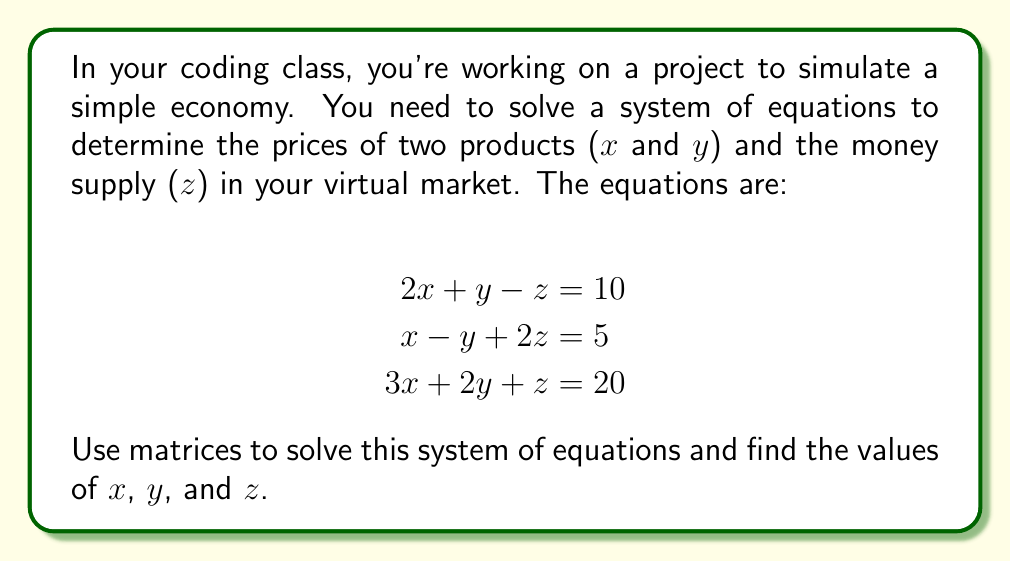Solve this math problem. Let's solve this step-by-step using matrices:

1) First, we'll set up the augmented matrix:

   $$\left[\begin{array}{ccc|c}
   2 & 1 & -1 & 10 \\
   1 & -1 & 2 & 5 \\
   3 & 2 & 1 & 20
   \end{array}\right]$$

2) Now, we'll use Gaussian elimination to convert this to row echelon form:

   R2 → R2 - $\frac{1}{2}$R1:
   $$\left[\begin{array}{ccc|c}
   2 & 1 & -1 & 10 \\
   0 & -\frac{3}{2} & \frac{5}{2} & 0 \\
   3 & 2 & 1 & 20
   \end{array}\right]$$

   R3 → R3 - $\frac{3}{2}$R1:
   $$\left[\begin{array}{ccc|c}
   2 & 1 & -1 & 10 \\
   0 & -\frac{3}{2} & \frac{5}{2} & 0 \\
   0 & \frac{1}{2} & \frac{5}{2} & 5
   \end{array}\right]$$

3) Now, R3 → R3 + $\frac{1}{3}$R2:
   $$\left[\begin{array}{ccc|c}
   2 & 1 & -1 & 10 \\
   0 & -\frac{3}{2} & \frac{5}{2} & 0 \\
   0 & 0 & 3 & 5
   \end{array}\right]$$

4) We now have the matrix in row echelon form. Let's solve from bottom to top:

   From the last row: $3z = 5$, so $z = \frac{5}{3}$

   From the second row: $-\frac{3}{2}y + \frac{5}{2}(\frac{5}{3}) = 0$
                        $-\frac{3}{2}y + \frac{25}{6} = 0$
                        $y = \frac{25}{9}$

   From the first row: $2x + \frac{25}{9} - \frac{5}{3} = 10$
                       $2x = 10 - \frac{25}{9} + \frac{5}{3} = \frac{90}{9} - \frac{25}{9} + \frac{15}{9} = \frac{80}{9}$
                       $x = \frac{40}{9}$

5) Therefore, the solution is:
   $x = \frac{40}{9}$, $y = \frac{25}{9}$, $z = \frac{5}{3}$
Answer: $x = \frac{40}{9}$, $y = \frac{25}{9}$, $z = \frac{5}{3}$ 